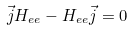<formula> <loc_0><loc_0><loc_500><loc_500>\vec { j } H _ { e e } - H _ { e e } \vec { j } = 0</formula> 